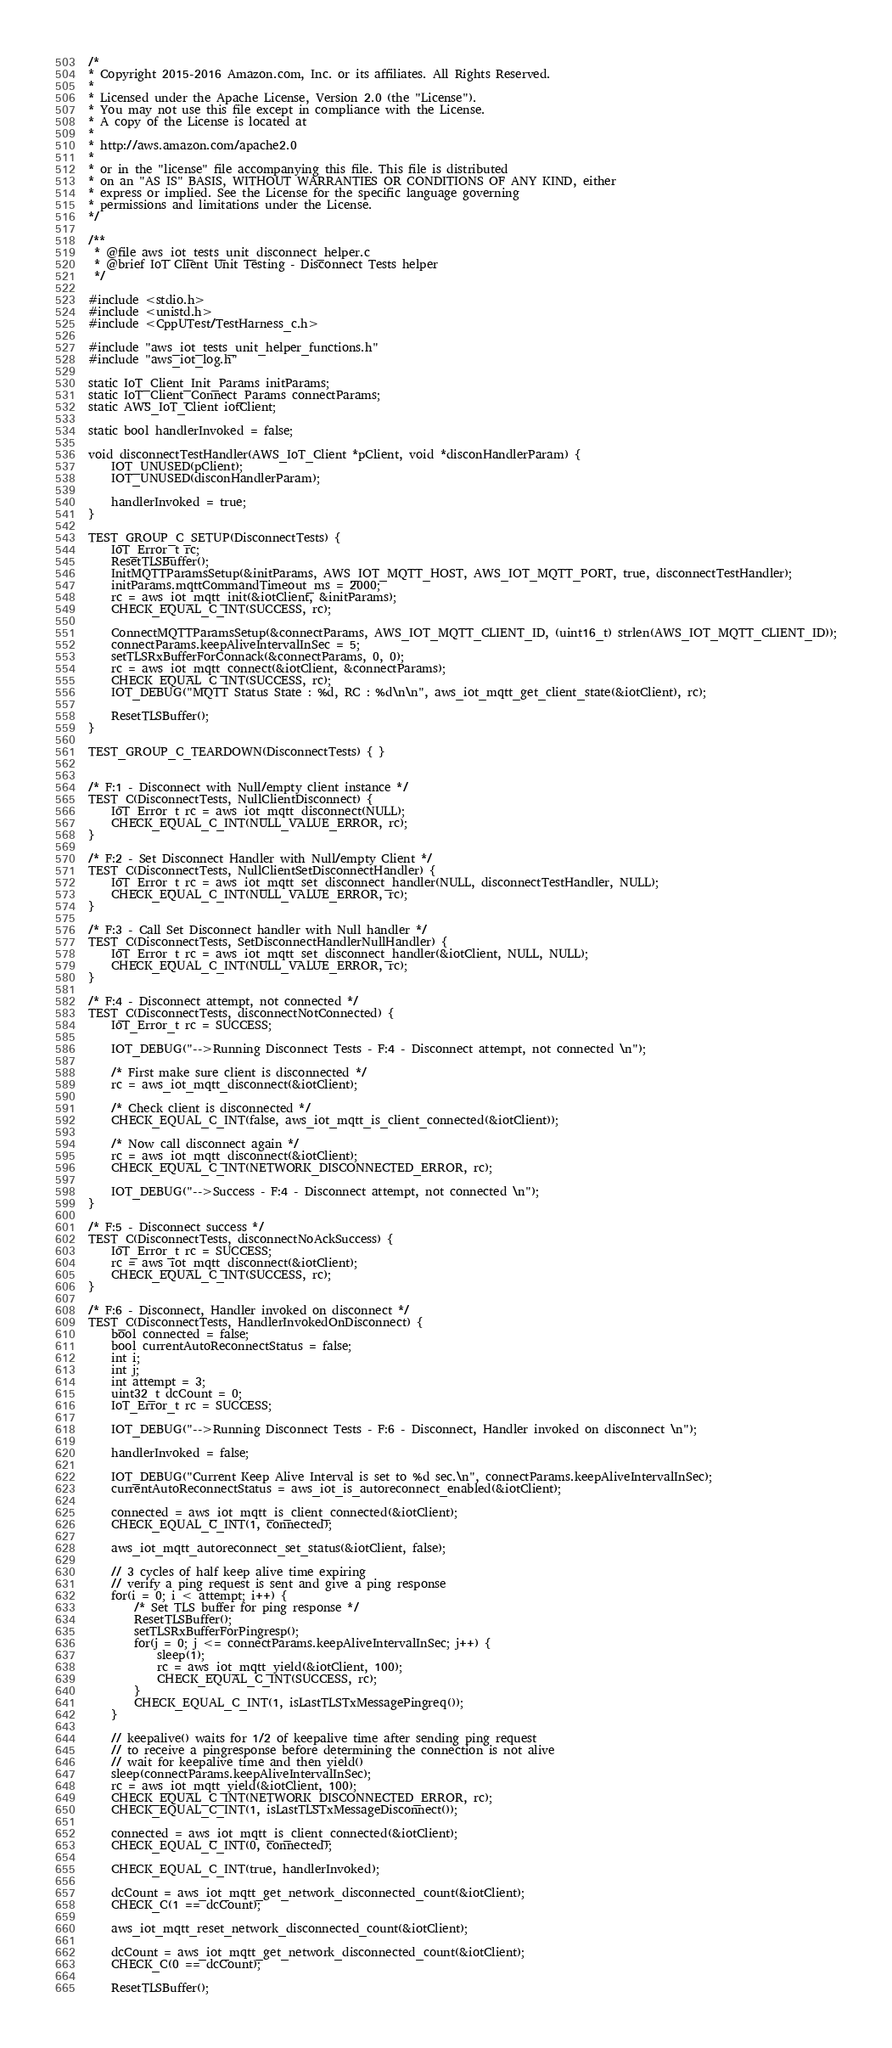Convert code to text. <code><loc_0><loc_0><loc_500><loc_500><_C_>/*
* Copyright 2015-2016 Amazon.com, Inc. or its affiliates. All Rights Reserved.
*
* Licensed under the Apache License, Version 2.0 (the "License").
* You may not use this file except in compliance with the License.
* A copy of the License is located at
*
* http://aws.amazon.com/apache2.0
*
* or in the "license" file accompanying this file. This file is distributed
* on an "AS IS" BASIS, WITHOUT WARRANTIES OR CONDITIONS OF ANY KIND, either
* express or implied. See the License for the specific language governing
* permissions and limitations under the License.
*/

/**
 * @file aws_iot_tests_unit_disconnect_helper.c
 * @brief IoT Client Unit Testing - Disconnect Tests helper
 */

#include <stdio.h>
#include <unistd.h>
#include <CppUTest/TestHarness_c.h>

#include "aws_iot_tests_unit_helper_functions.h"
#include "aws_iot_log.h"

static IoT_Client_Init_Params initParams;
static IoT_Client_Connect_Params connectParams;
static AWS_IoT_Client iotClient;

static bool handlerInvoked = false;

void disconnectTestHandler(AWS_IoT_Client *pClient, void *disconHandlerParam) {
	IOT_UNUSED(pClient);
	IOT_UNUSED(disconHandlerParam);

	handlerInvoked = true;
}

TEST_GROUP_C_SETUP(DisconnectTests) {
	IoT_Error_t rc;
	ResetTLSBuffer();
	InitMQTTParamsSetup(&initParams, AWS_IOT_MQTT_HOST, AWS_IOT_MQTT_PORT, true, disconnectTestHandler);
	initParams.mqttCommandTimeout_ms = 2000;
	rc = aws_iot_mqtt_init(&iotClient, &initParams);
	CHECK_EQUAL_C_INT(SUCCESS, rc);

	ConnectMQTTParamsSetup(&connectParams, AWS_IOT_MQTT_CLIENT_ID, (uint16_t) strlen(AWS_IOT_MQTT_CLIENT_ID));
	connectParams.keepAliveIntervalInSec = 5;
	setTLSRxBufferForConnack(&connectParams, 0, 0);
	rc = aws_iot_mqtt_connect(&iotClient, &connectParams);
	CHECK_EQUAL_C_INT(SUCCESS, rc);
	IOT_DEBUG("MQTT Status State : %d, RC : %d\n\n", aws_iot_mqtt_get_client_state(&iotClient), rc);

	ResetTLSBuffer();
}

TEST_GROUP_C_TEARDOWN(DisconnectTests) { }


/* F:1 - Disconnect with Null/empty client instance */
TEST_C(DisconnectTests, NullClientDisconnect) {
	IoT_Error_t rc = aws_iot_mqtt_disconnect(NULL);
	CHECK_EQUAL_C_INT(NULL_VALUE_ERROR, rc);
}

/* F:2 - Set Disconnect Handler with Null/empty Client */
TEST_C(DisconnectTests, NullClientSetDisconnectHandler) {
	IoT_Error_t rc = aws_iot_mqtt_set_disconnect_handler(NULL, disconnectTestHandler, NULL);
	CHECK_EQUAL_C_INT(NULL_VALUE_ERROR, rc);
}

/* F:3 - Call Set Disconnect handler with Null handler */
TEST_C(DisconnectTests, SetDisconnectHandlerNullHandler) {
	IoT_Error_t rc = aws_iot_mqtt_set_disconnect_handler(&iotClient, NULL, NULL);
	CHECK_EQUAL_C_INT(NULL_VALUE_ERROR, rc);
}

/* F:4 - Disconnect attempt, not connected */
TEST_C(DisconnectTests, disconnectNotConnected) {
	IoT_Error_t rc = SUCCESS;

	IOT_DEBUG("-->Running Disconnect Tests - F:4 - Disconnect attempt, not connected \n");

	/* First make sure client is disconnected */
	rc = aws_iot_mqtt_disconnect(&iotClient);

	/* Check client is disconnected */
	CHECK_EQUAL_C_INT(false, aws_iot_mqtt_is_client_connected(&iotClient));

	/* Now call disconnect again */
	rc = aws_iot_mqtt_disconnect(&iotClient);
	CHECK_EQUAL_C_INT(NETWORK_DISCONNECTED_ERROR, rc);

	IOT_DEBUG("-->Success - F:4 - Disconnect attempt, not connected \n");
}

/* F:5 - Disconnect success */
TEST_C(DisconnectTests, disconnectNoAckSuccess) {
	IoT_Error_t rc = SUCCESS;
	rc = aws_iot_mqtt_disconnect(&iotClient);
	CHECK_EQUAL_C_INT(SUCCESS, rc);
}

/* F:6 - Disconnect, Handler invoked on disconnect */
TEST_C(DisconnectTests, HandlerInvokedOnDisconnect) {
	bool connected = false;
	bool currentAutoReconnectStatus = false;
	int i;
	int j;
	int attempt = 3;
	uint32_t dcCount = 0;
	IoT_Error_t rc = SUCCESS;

	IOT_DEBUG("-->Running Disconnect Tests - F:6 - Disconnect, Handler invoked on disconnect \n");

	handlerInvoked = false;

	IOT_DEBUG("Current Keep Alive Interval is set to %d sec.\n", connectParams.keepAliveIntervalInSec);
	currentAutoReconnectStatus = aws_iot_is_autoreconnect_enabled(&iotClient);

	connected = aws_iot_mqtt_is_client_connected(&iotClient);
	CHECK_EQUAL_C_INT(1, connected);

	aws_iot_mqtt_autoreconnect_set_status(&iotClient, false);

	// 3 cycles of half keep alive time expiring
	// verify a ping request is sent and give a ping response
	for(i = 0; i < attempt; i++) {
		/* Set TLS buffer for ping response */
		ResetTLSBuffer();
		setTLSRxBufferForPingresp();
		for(j = 0; j <= connectParams.keepAliveIntervalInSec; j++) {
			sleep(1);
			rc = aws_iot_mqtt_yield(&iotClient, 100);
			CHECK_EQUAL_C_INT(SUCCESS, rc);
		}
		CHECK_EQUAL_C_INT(1, isLastTLSTxMessagePingreq());
	}

	// keepalive() waits for 1/2 of keepalive time after sending ping request
	// to receive a pingresponse before determining the connection is not alive
	// wait for keepalive time and then yield()
	sleep(connectParams.keepAliveIntervalInSec);
	rc = aws_iot_mqtt_yield(&iotClient, 100);
	CHECK_EQUAL_C_INT(NETWORK_DISCONNECTED_ERROR, rc);
	CHECK_EQUAL_C_INT(1, isLastTLSTxMessageDisconnect());

	connected = aws_iot_mqtt_is_client_connected(&iotClient);
	CHECK_EQUAL_C_INT(0, connected);

	CHECK_EQUAL_C_INT(true, handlerInvoked);

	dcCount = aws_iot_mqtt_get_network_disconnected_count(&iotClient);
	CHECK_C(1 == dcCount);

	aws_iot_mqtt_reset_network_disconnected_count(&iotClient);

	dcCount = aws_iot_mqtt_get_network_disconnected_count(&iotClient);
	CHECK_C(0 == dcCount);

	ResetTLSBuffer();</code> 